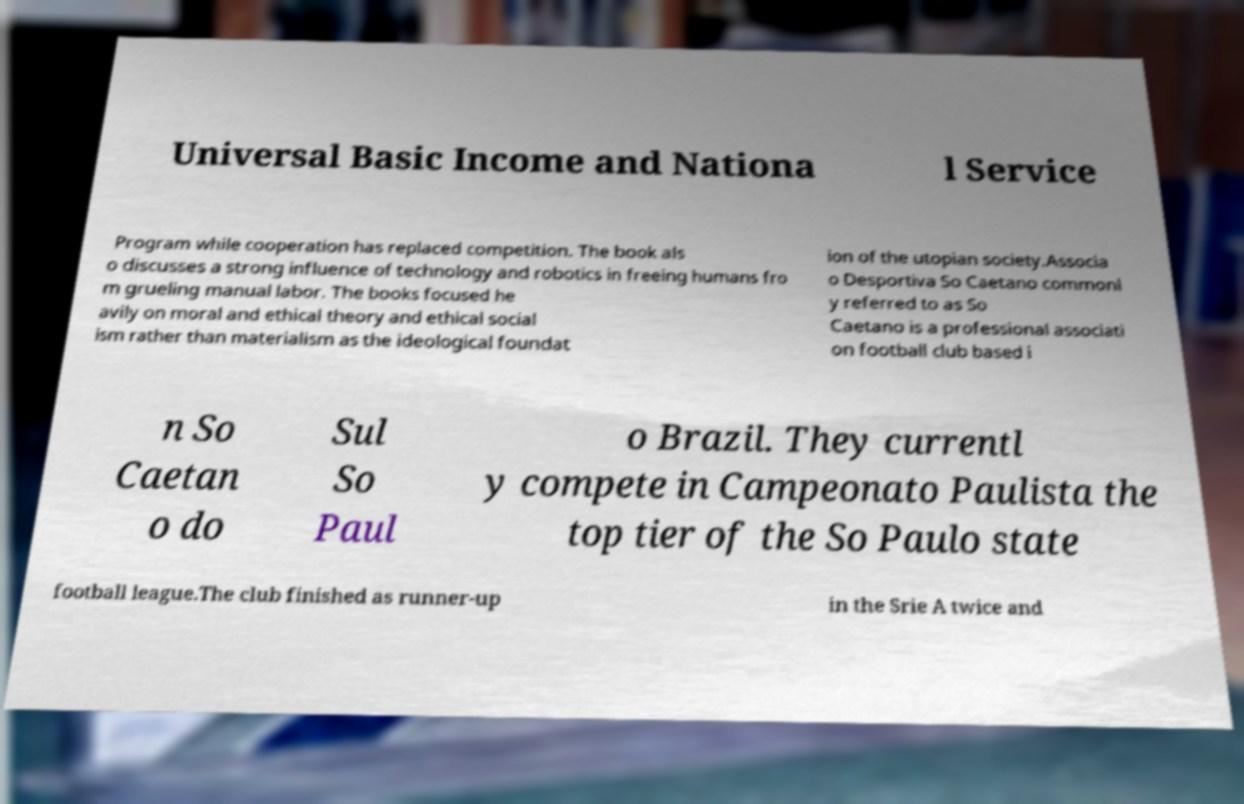There's text embedded in this image that I need extracted. Can you transcribe it verbatim? Universal Basic Income and Nationa l Service Program while cooperation has replaced competition. The book als o discusses a strong influence of technology and robotics in freeing humans fro m grueling manual labor. The books focused he avily on moral and ethical theory and ethical social ism rather than materialism as the ideological foundat ion of the utopian society.Associa o Desportiva So Caetano commonl y referred to as So Caetano is a professional associati on football club based i n So Caetan o do Sul So Paul o Brazil. They currentl y compete in Campeonato Paulista the top tier of the So Paulo state football league.The club finished as runner-up in the Srie A twice and 